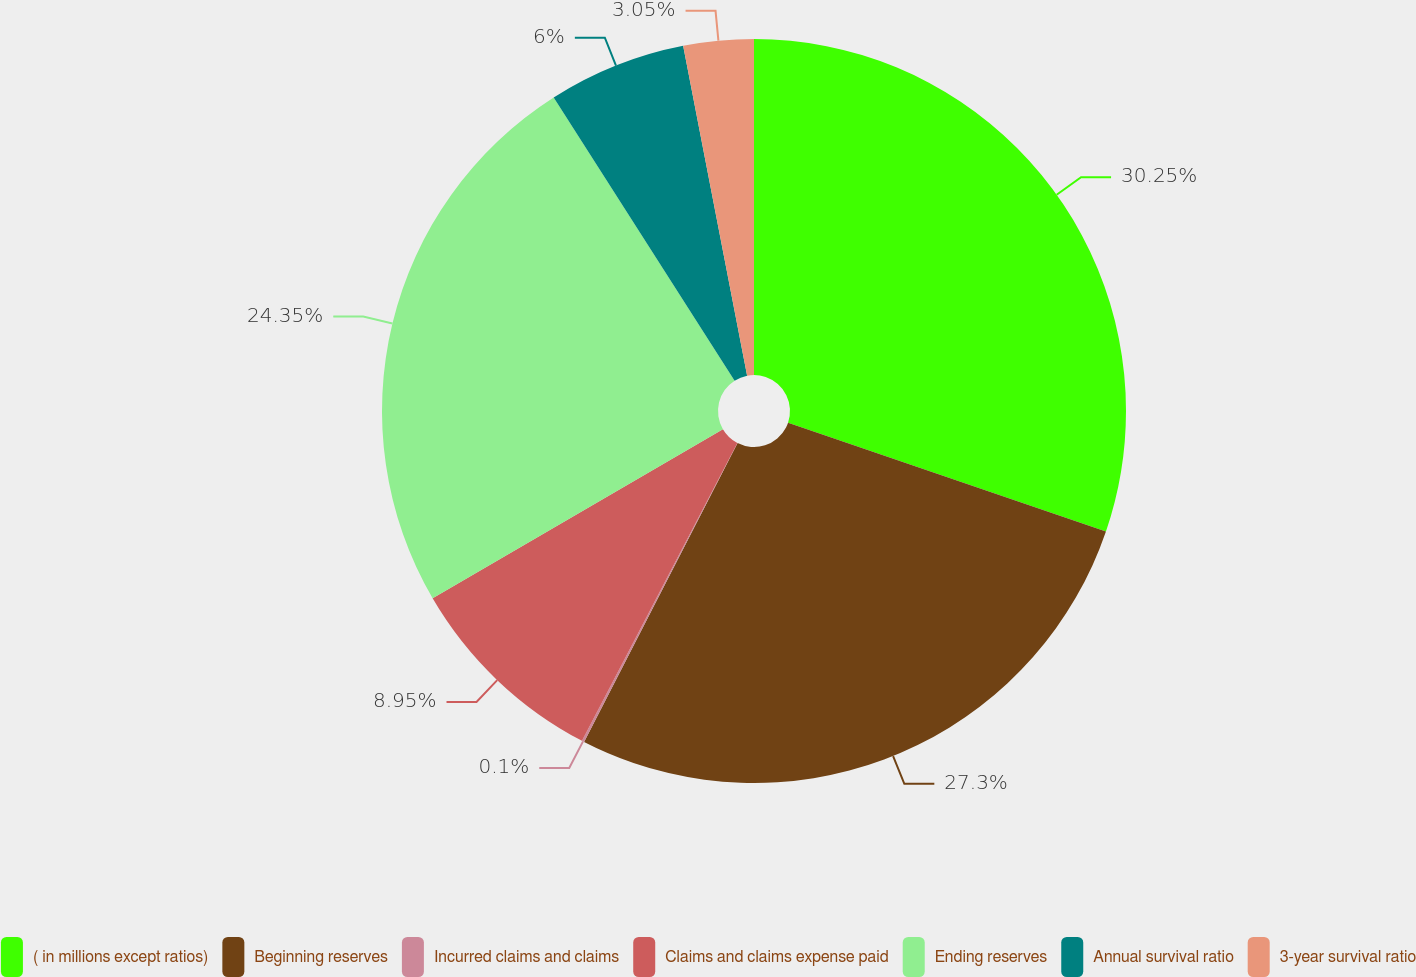Convert chart. <chart><loc_0><loc_0><loc_500><loc_500><pie_chart><fcel>( in millions except ratios)<fcel>Beginning reserves<fcel>Incurred claims and claims<fcel>Claims and claims expense paid<fcel>Ending reserves<fcel>Annual survival ratio<fcel>3-year survival ratio<nl><fcel>30.25%<fcel>27.3%<fcel>0.1%<fcel>8.95%<fcel>24.35%<fcel>6.0%<fcel>3.05%<nl></chart> 